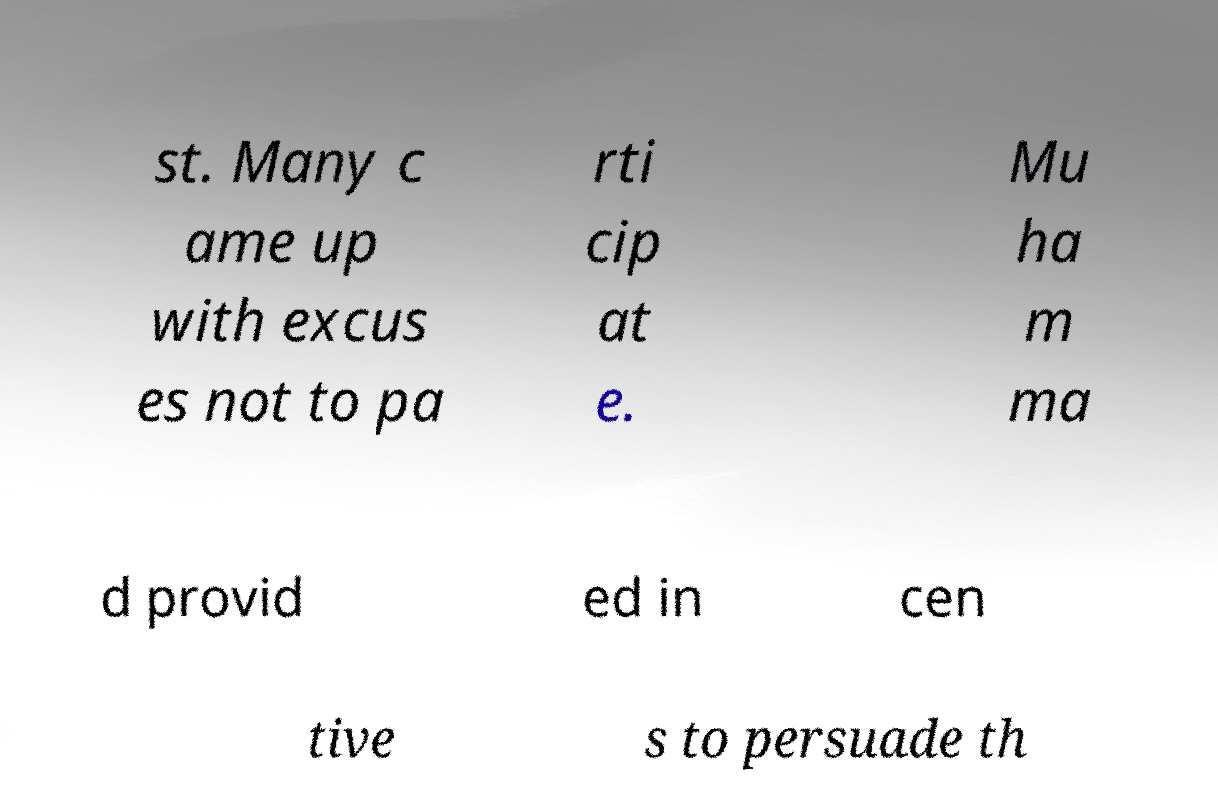Could you assist in decoding the text presented in this image and type it out clearly? st. Many c ame up with excus es not to pa rti cip at e. Mu ha m ma d provid ed in cen tive s to persuade th 